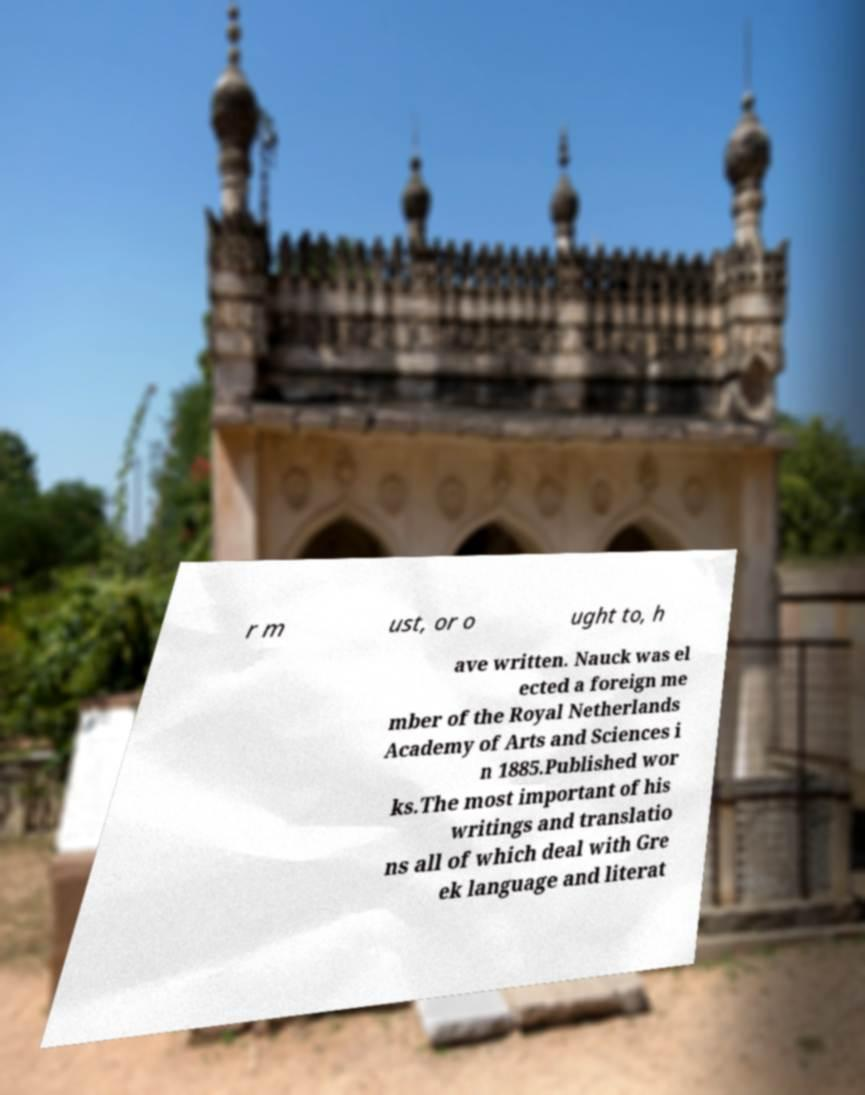For documentation purposes, I need the text within this image transcribed. Could you provide that? r m ust, or o ught to, h ave written. Nauck was el ected a foreign me mber of the Royal Netherlands Academy of Arts and Sciences i n 1885.Published wor ks.The most important of his writings and translatio ns all of which deal with Gre ek language and literat 